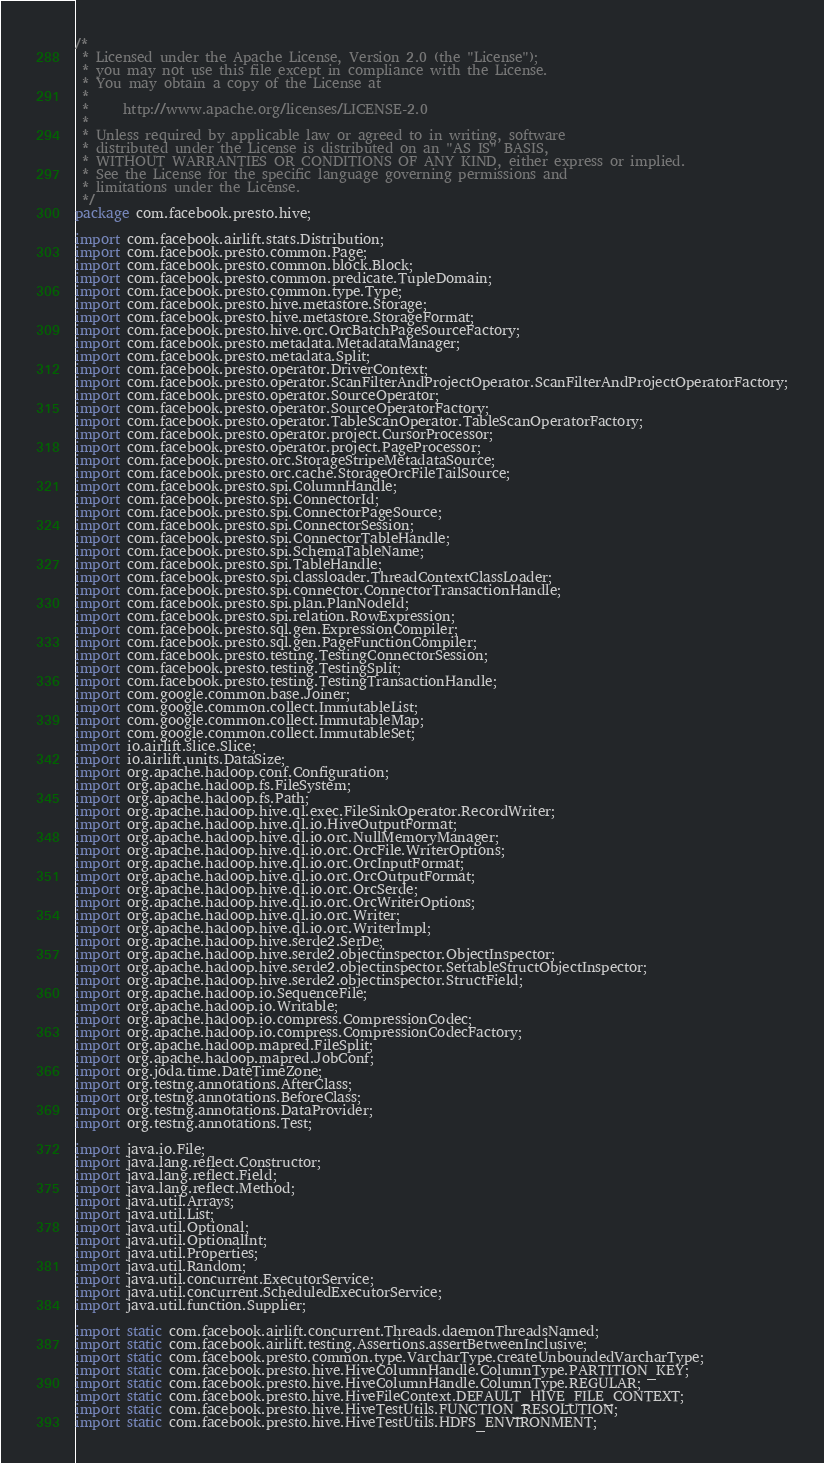Convert code to text. <code><loc_0><loc_0><loc_500><loc_500><_Java_>/*
 * Licensed under the Apache License, Version 2.0 (the "License");
 * you may not use this file except in compliance with the License.
 * You may obtain a copy of the License at
 *
 *     http://www.apache.org/licenses/LICENSE-2.0
 *
 * Unless required by applicable law or agreed to in writing, software
 * distributed under the License is distributed on an "AS IS" BASIS,
 * WITHOUT WARRANTIES OR CONDITIONS OF ANY KIND, either express or implied.
 * See the License for the specific language governing permissions and
 * limitations under the License.
 */
package com.facebook.presto.hive;

import com.facebook.airlift.stats.Distribution;
import com.facebook.presto.common.Page;
import com.facebook.presto.common.block.Block;
import com.facebook.presto.common.predicate.TupleDomain;
import com.facebook.presto.common.type.Type;
import com.facebook.presto.hive.metastore.Storage;
import com.facebook.presto.hive.metastore.StorageFormat;
import com.facebook.presto.hive.orc.OrcBatchPageSourceFactory;
import com.facebook.presto.metadata.MetadataManager;
import com.facebook.presto.metadata.Split;
import com.facebook.presto.operator.DriverContext;
import com.facebook.presto.operator.ScanFilterAndProjectOperator.ScanFilterAndProjectOperatorFactory;
import com.facebook.presto.operator.SourceOperator;
import com.facebook.presto.operator.SourceOperatorFactory;
import com.facebook.presto.operator.TableScanOperator.TableScanOperatorFactory;
import com.facebook.presto.operator.project.CursorProcessor;
import com.facebook.presto.operator.project.PageProcessor;
import com.facebook.presto.orc.StorageStripeMetadataSource;
import com.facebook.presto.orc.cache.StorageOrcFileTailSource;
import com.facebook.presto.spi.ColumnHandle;
import com.facebook.presto.spi.ConnectorId;
import com.facebook.presto.spi.ConnectorPageSource;
import com.facebook.presto.spi.ConnectorSession;
import com.facebook.presto.spi.ConnectorTableHandle;
import com.facebook.presto.spi.SchemaTableName;
import com.facebook.presto.spi.TableHandle;
import com.facebook.presto.spi.classloader.ThreadContextClassLoader;
import com.facebook.presto.spi.connector.ConnectorTransactionHandle;
import com.facebook.presto.spi.plan.PlanNodeId;
import com.facebook.presto.spi.relation.RowExpression;
import com.facebook.presto.sql.gen.ExpressionCompiler;
import com.facebook.presto.sql.gen.PageFunctionCompiler;
import com.facebook.presto.testing.TestingConnectorSession;
import com.facebook.presto.testing.TestingSplit;
import com.facebook.presto.testing.TestingTransactionHandle;
import com.google.common.base.Joiner;
import com.google.common.collect.ImmutableList;
import com.google.common.collect.ImmutableMap;
import com.google.common.collect.ImmutableSet;
import io.airlift.slice.Slice;
import io.airlift.units.DataSize;
import org.apache.hadoop.conf.Configuration;
import org.apache.hadoop.fs.FileSystem;
import org.apache.hadoop.fs.Path;
import org.apache.hadoop.hive.ql.exec.FileSinkOperator.RecordWriter;
import org.apache.hadoop.hive.ql.io.HiveOutputFormat;
import org.apache.hadoop.hive.ql.io.orc.NullMemoryManager;
import org.apache.hadoop.hive.ql.io.orc.OrcFile.WriterOptions;
import org.apache.hadoop.hive.ql.io.orc.OrcInputFormat;
import org.apache.hadoop.hive.ql.io.orc.OrcOutputFormat;
import org.apache.hadoop.hive.ql.io.orc.OrcSerde;
import org.apache.hadoop.hive.ql.io.orc.OrcWriterOptions;
import org.apache.hadoop.hive.ql.io.orc.Writer;
import org.apache.hadoop.hive.ql.io.orc.WriterImpl;
import org.apache.hadoop.hive.serde2.SerDe;
import org.apache.hadoop.hive.serde2.objectinspector.ObjectInspector;
import org.apache.hadoop.hive.serde2.objectinspector.SettableStructObjectInspector;
import org.apache.hadoop.hive.serde2.objectinspector.StructField;
import org.apache.hadoop.io.SequenceFile;
import org.apache.hadoop.io.Writable;
import org.apache.hadoop.io.compress.CompressionCodec;
import org.apache.hadoop.io.compress.CompressionCodecFactory;
import org.apache.hadoop.mapred.FileSplit;
import org.apache.hadoop.mapred.JobConf;
import org.joda.time.DateTimeZone;
import org.testng.annotations.AfterClass;
import org.testng.annotations.BeforeClass;
import org.testng.annotations.DataProvider;
import org.testng.annotations.Test;

import java.io.File;
import java.lang.reflect.Constructor;
import java.lang.reflect.Field;
import java.lang.reflect.Method;
import java.util.Arrays;
import java.util.List;
import java.util.Optional;
import java.util.OptionalInt;
import java.util.Properties;
import java.util.Random;
import java.util.concurrent.ExecutorService;
import java.util.concurrent.ScheduledExecutorService;
import java.util.function.Supplier;

import static com.facebook.airlift.concurrent.Threads.daemonThreadsNamed;
import static com.facebook.airlift.testing.Assertions.assertBetweenInclusive;
import static com.facebook.presto.common.type.VarcharType.createUnboundedVarcharType;
import static com.facebook.presto.hive.HiveColumnHandle.ColumnType.PARTITION_KEY;
import static com.facebook.presto.hive.HiveColumnHandle.ColumnType.REGULAR;
import static com.facebook.presto.hive.HiveFileContext.DEFAULT_HIVE_FILE_CONTEXT;
import static com.facebook.presto.hive.HiveTestUtils.FUNCTION_RESOLUTION;
import static com.facebook.presto.hive.HiveTestUtils.HDFS_ENVIRONMENT;</code> 